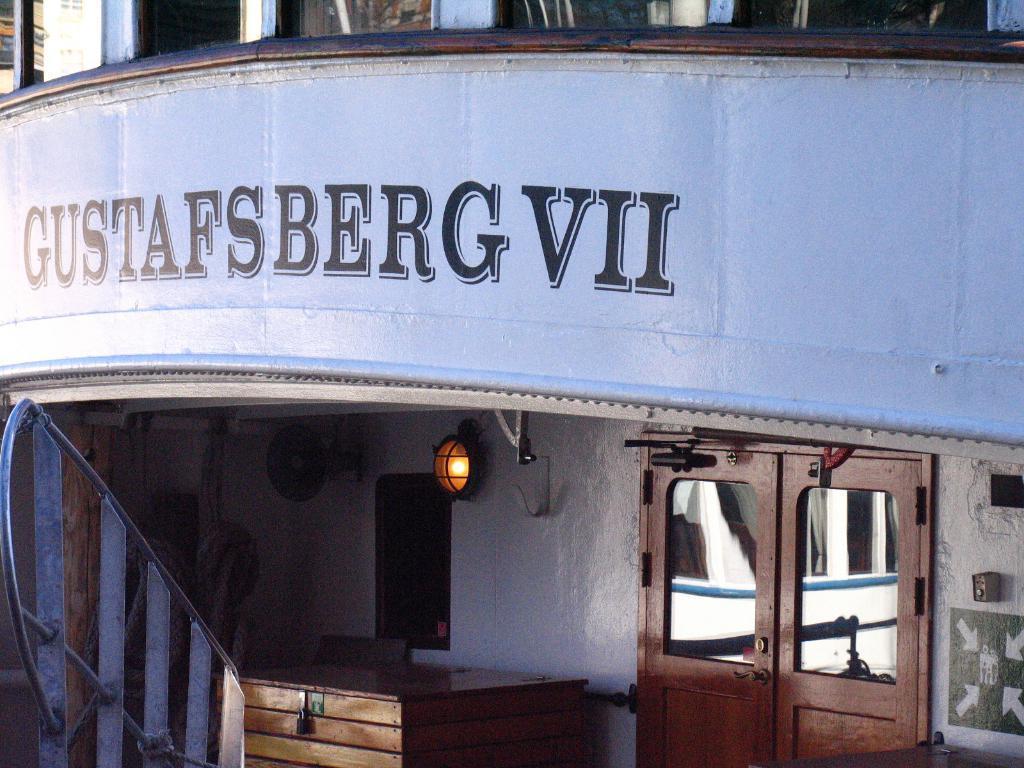Could you give a brief overview of what you see in this image? This is a building and here we can see some text on the wall and there are railings and we can see a light, a wooden box and there are doors. 